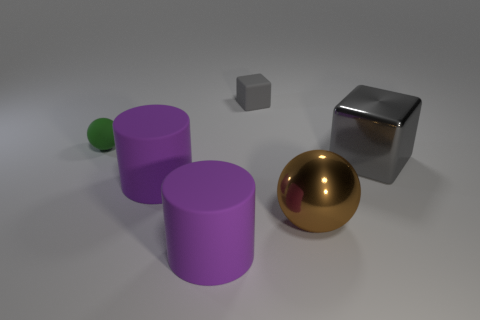Can you describe the lighting and shadows in the image? The image has soft, diffuse lighting that casts gentle shadows. The shadows on the ground help to give a sense of depth and position of the objects. The light source seems to be coming from above and slightly to the right, as indicated by the shadows being cast to the left of the objects. How does the lighting affect the appearance of the materials? The lighting emphasizes the different material properties of each object. The smooth and shiny surfaces, like the golden sphere, reflect more light and thus appear brighter and more reflective. The matte surfaces, like the gray cube, scatter the light more evenly and hence don't have strong highlights or reflections. This effect enhances the visual cues that suggest what each object is made from. 